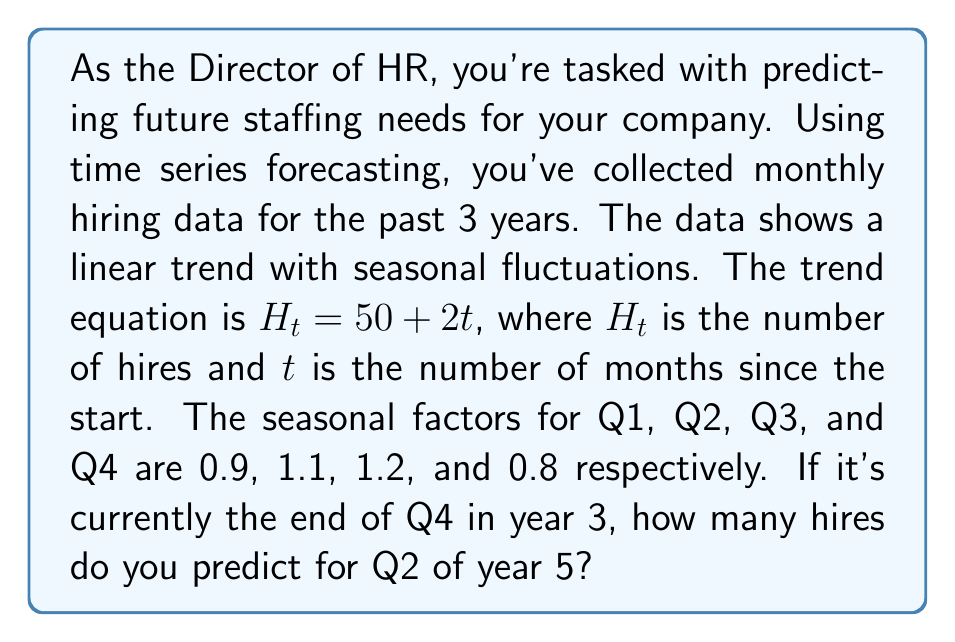Can you answer this question? To solve this problem, we'll follow these steps:

1. Determine the value of $t$ for Q2 of year 5.
2. Calculate the trend value using the equation $H_t = 50 + 2t$.
3. Apply the seasonal factor for Q2.

Step 1: Determining $t$
- Current time: End of Q4, Year 3 (t = 36 months)
- Target time: Q2, Year 5
- Months between: 4 (Q1 Year 4) + 3 (Q2 Year 5) = 7 months
- So, $t = 36 + 7 = 43$

Step 2: Calculating the trend value
$$H_t = 50 + 2t = 50 + 2(43) = 50 + 86 = 136$$

Step 3: Applying the seasonal factor
- Q2 seasonal factor: 1.1
- Predicted hires = Trend value × Seasonal factor
$$\text{Predicted hires} = 136 \times 1.1 = 149.6$$

Since we're dealing with whole numbers of hires, we round to the nearest integer.
Answer: 150 hires 